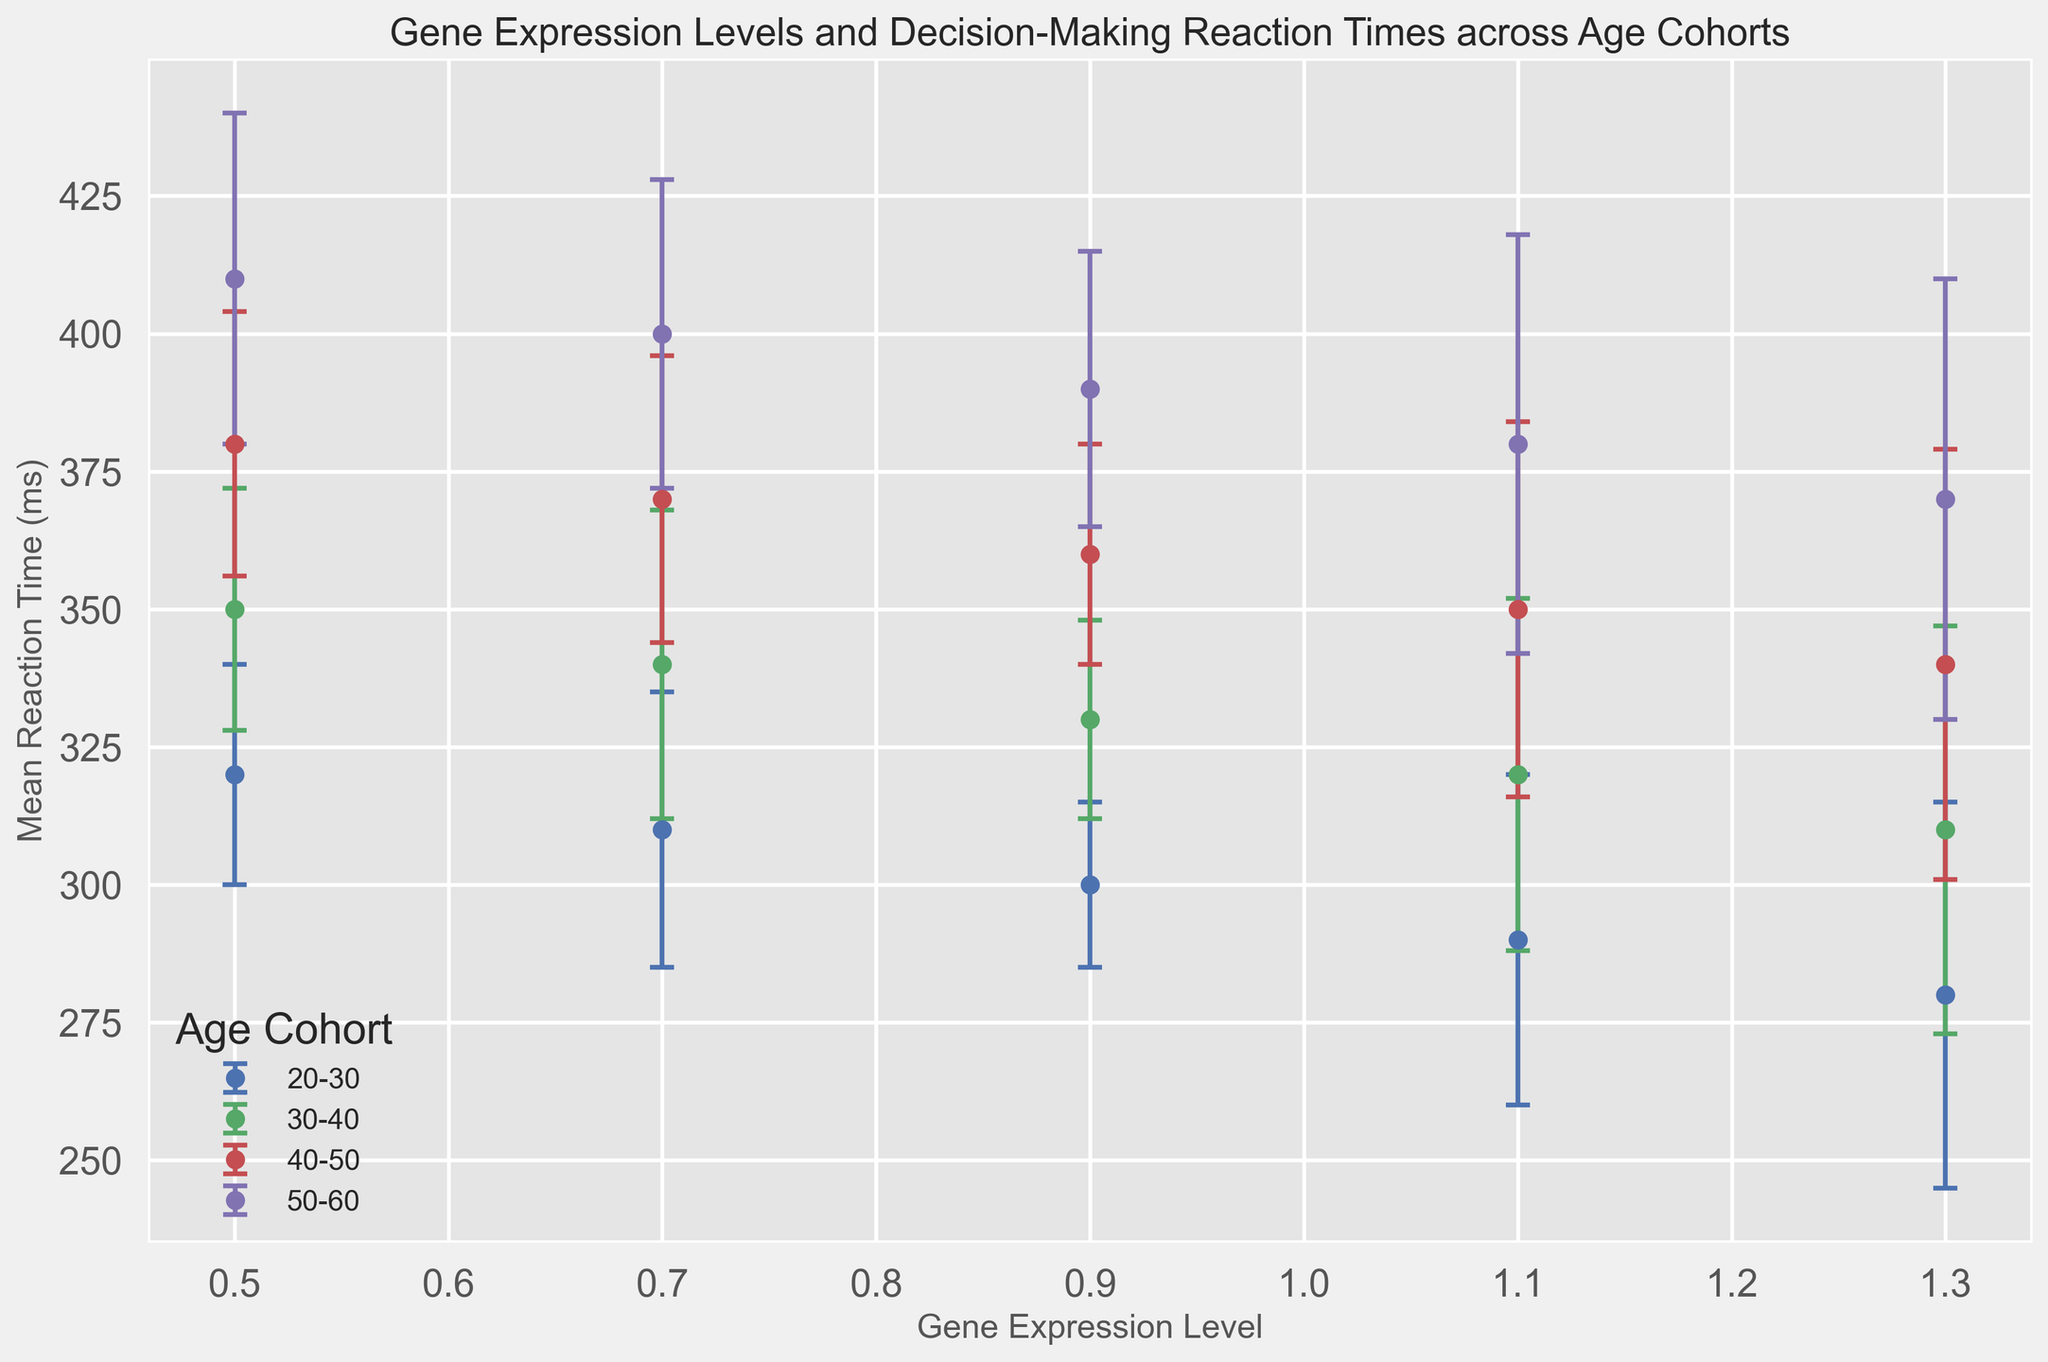Which age cohort had the lowest mean reaction time at the highest gene expression level? Look at the data points corresponding to gene expression level 1.3 and compare the mean reaction times across different age cohorts. The 20-30 age cohort has a mean reaction time of 280 ms, which is the lowest.
Answer: 20-30 What is the difference in mean reaction times between the 20-30 and 50-60 age cohorts at a gene expression level of 0.7? Identify the mean reaction times at gene expression level 0.7 for the 20-30 (310 ms) and 50-60 (400 ms) age cohorts. Subtract the former from the latter: 400 - 310 = 90.
Answer: 90 Which age cohort shows the widest error bars at a gene expression level of 1.3? Observe the error bars at gene expression level 1.3 across different age cohorts. The 50-60 age cohort has the widest error bars, with a standard deviation of 40.
Answer: 50-60 Is there a general trend in mean reaction time across age cohorts as the gene expression level increases? Observe the trends in mean reaction times for each age cohort as gene expression levels go from 0.5 to 1.3. Mean reaction times decrease consistently across all age cohorts.
Answer: Decreasing Between which two consecutive gene expression levels does the mean reaction time decrease the most for the 40-50 age cohort? Calculate the differences in mean reaction times for the 40-50 age cohort between consecutive gene expression levels: 380-370=10, 370-360=10, 360-350=10, 350-340=10. Since decreases are equal, the difference is the same (10 ms) between all consecutive levels.
Answer: 0.5-0.7, 0.7-0.9, 0.9-1.1, 1.1-1.3 How does the variation in reaction times compare among age cohorts at the lowest gene expression level? Compare the standard deviation (error bars) at gene expression level 0.5 across age cohorts: 20-30 (20 ms), 30-40 (22 ms), 40-50 (24 ms), and 50-60 (30 ms). The 50-60 age cohort has the largest variation.
Answer: 50-60 Do any of the age cohorts have overlapping error bars at the 1.1 gene expression level? Examine the error bars at gene expression level 1.1. The intervals for all age cohorts are sufficiently spaced, and there is no overlap.
Answer: No What's the average mean reaction time for the 30-40 age cohort across all gene expression levels? Sum the mean reaction times for the 30-40 age cohort: 350 + 340 + 330 + 320 + 310 = 1,650 ms. Divide by the number of data points (5): 1,650 / 5 = 330 ms.
Answer: 330 